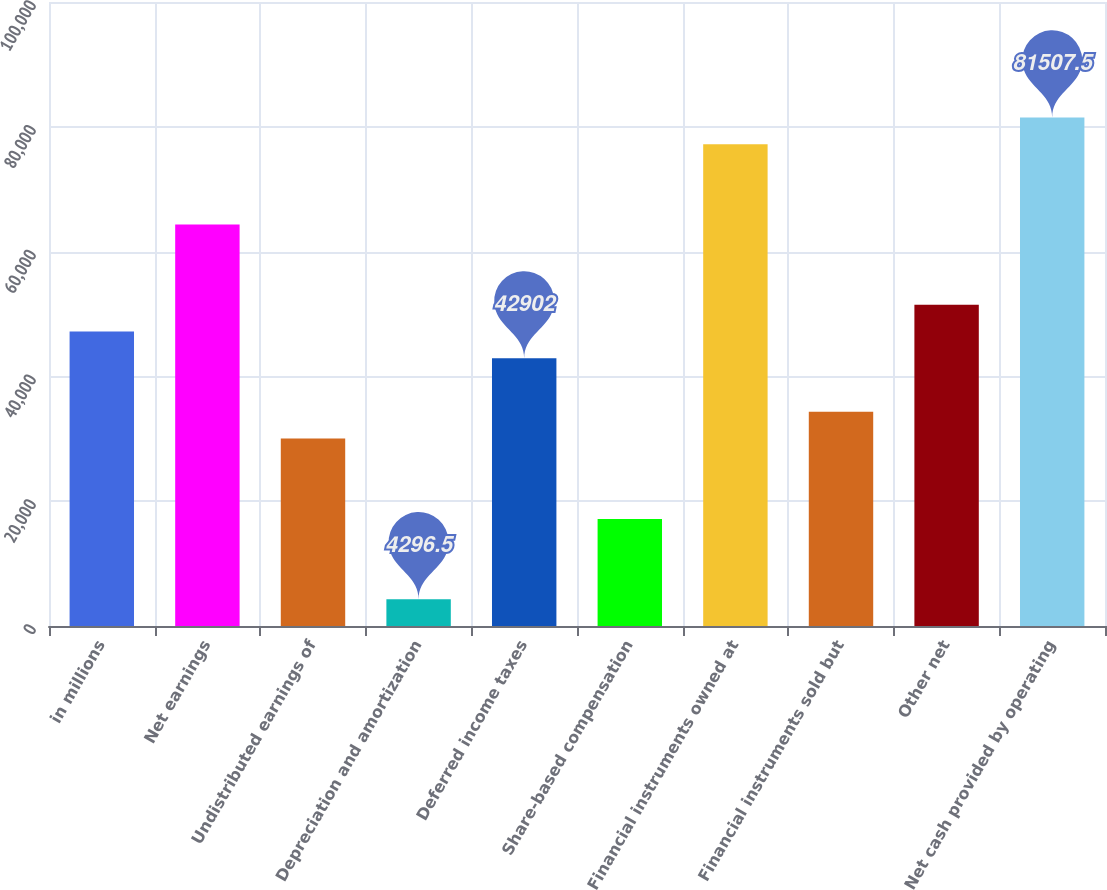<chart> <loc_0><loc_0><loc_500><loc_500><bar_chart><fcel>in millions<fcel>Net earnings<fcel>Undistributed earnings of<fcel>Depreciation and amortization<fcel>Deferred income taxes<fcel>Share-based compensation<fcel>Financial instruments owned at<fcel>Financial instruments sold but<fcel>Other net<fcel>Net cash provided by operating<nl><fcel>47191.5<fcel>64349.5<fcel>30033.5<fcel>4296.5<fcel>42902<fcel>17165<fcel>77218<fcel>34323<fcel>51481<fcel>81507.5<nl></chart> 